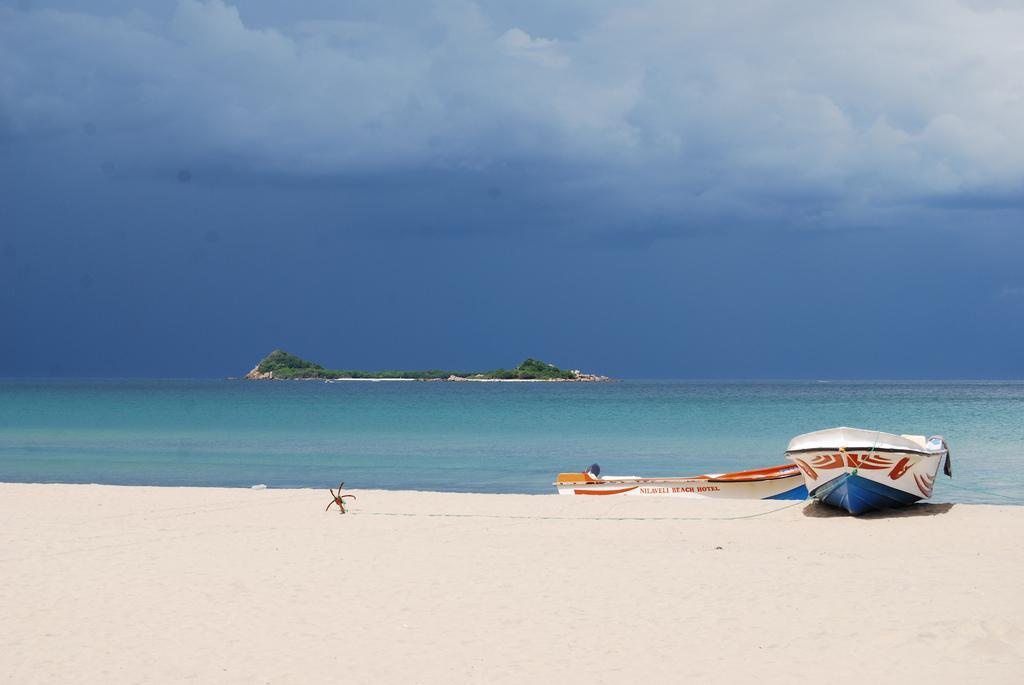Please provide a concise description of this image. In this picture I can see the boats on the right side. I can see water. I can see trees. I can see sand. I can see clouds in the sky. 